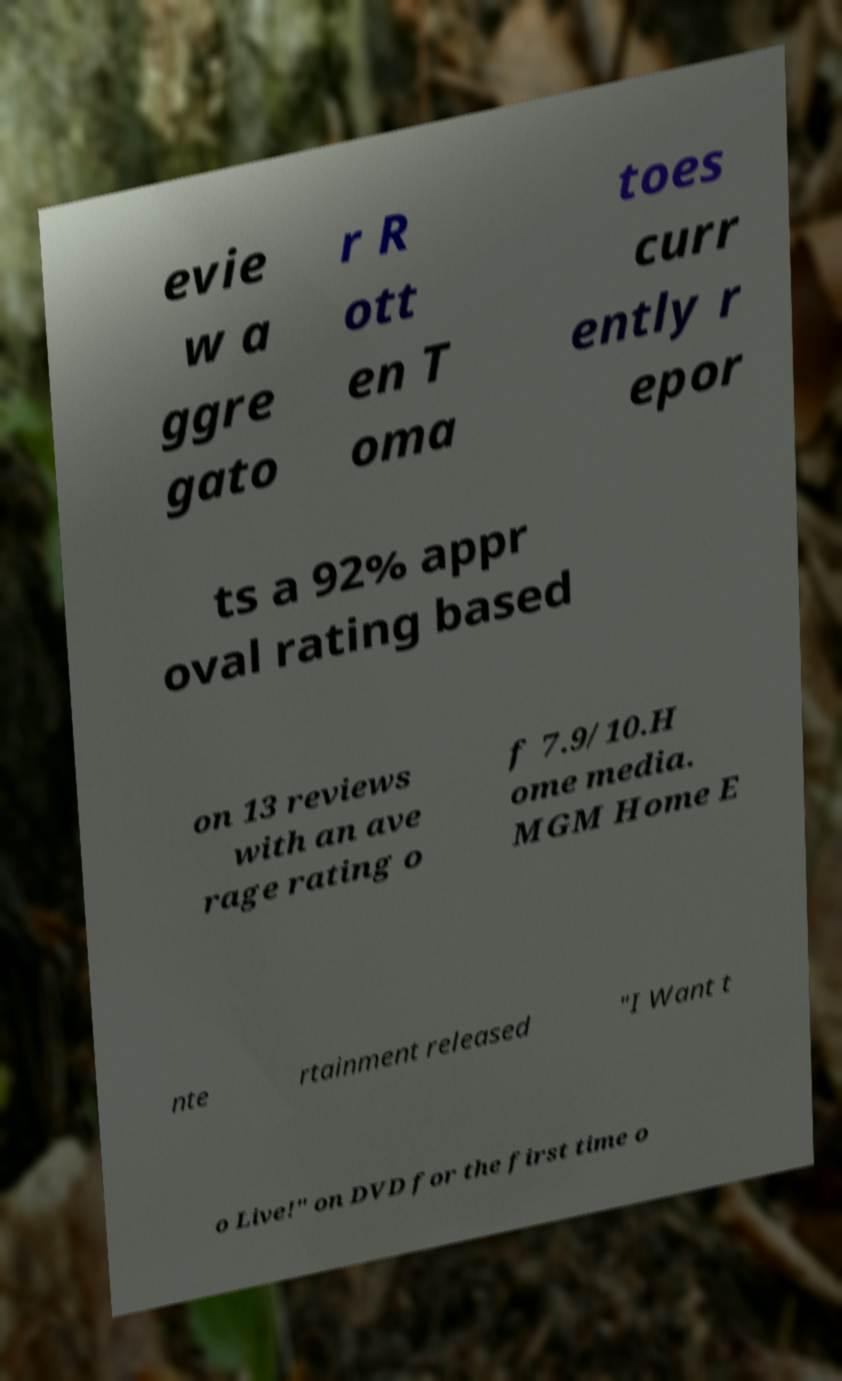Can you read and provide the text displayed in the image?This photo seems to have some interesting text. Can you extract and type it out for me? evie w a ggre gato r R ott en T oma toes curr ently r epor ts a 92% appr oval rating based on 13 reviews with an ave rage rating o f 7.9/10.H ome media. MGM Home E nte rtainment released "I Want t o Live!" on DVD for the first time o 